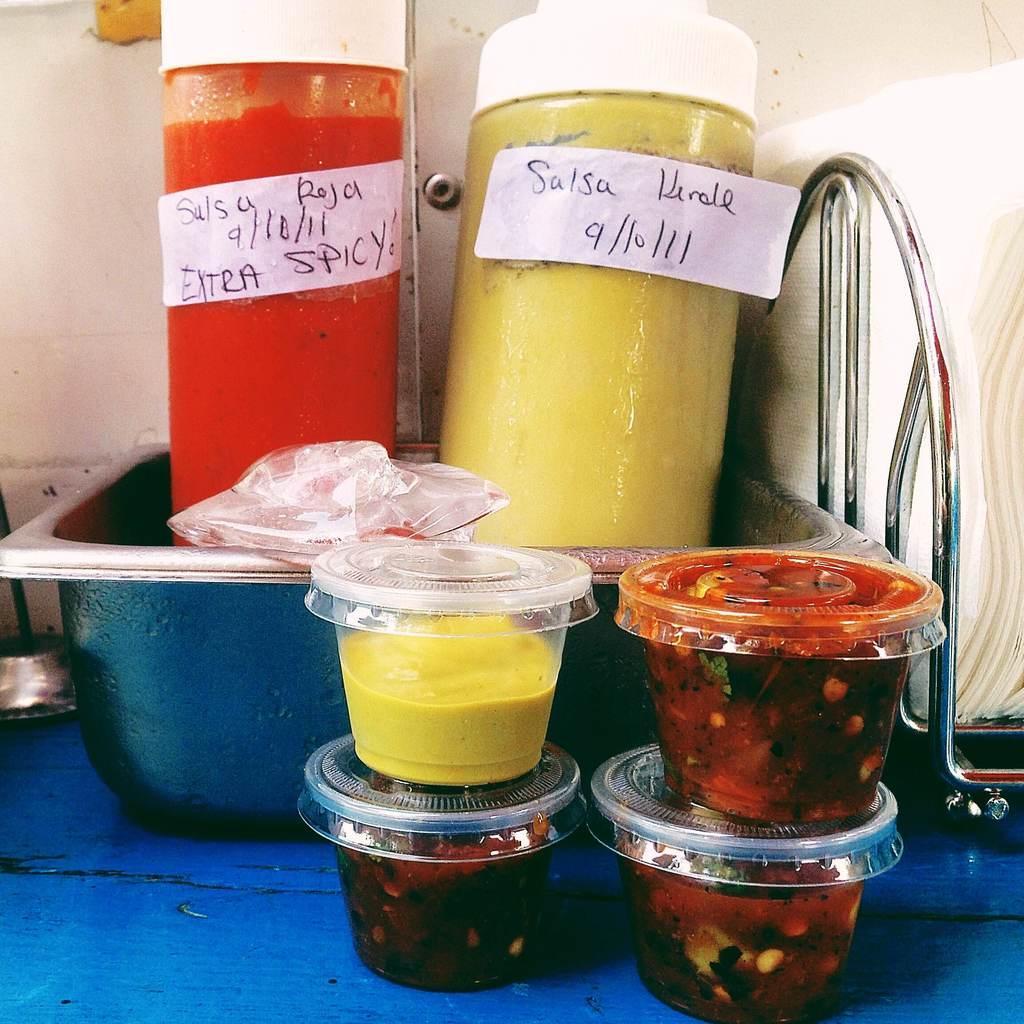How would you summarize this image in a sentence or two? In the given picture there are some cups which are filled with some sweets. There is a bowl on which two jars are placed. One jar is containing a red colored spicy food and the another jar is containing yellow color food. Behind them there is a wall. 